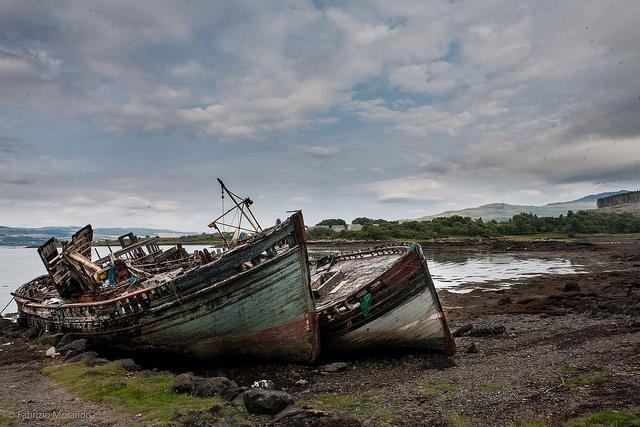Are these boats functional?
Short answer required. No. Where is the boat?
Concise answer only. Beached. What material was the boats made of?
Give a very brief answer. Wood. What is the weather like?
Be succinct. Cloudy. 